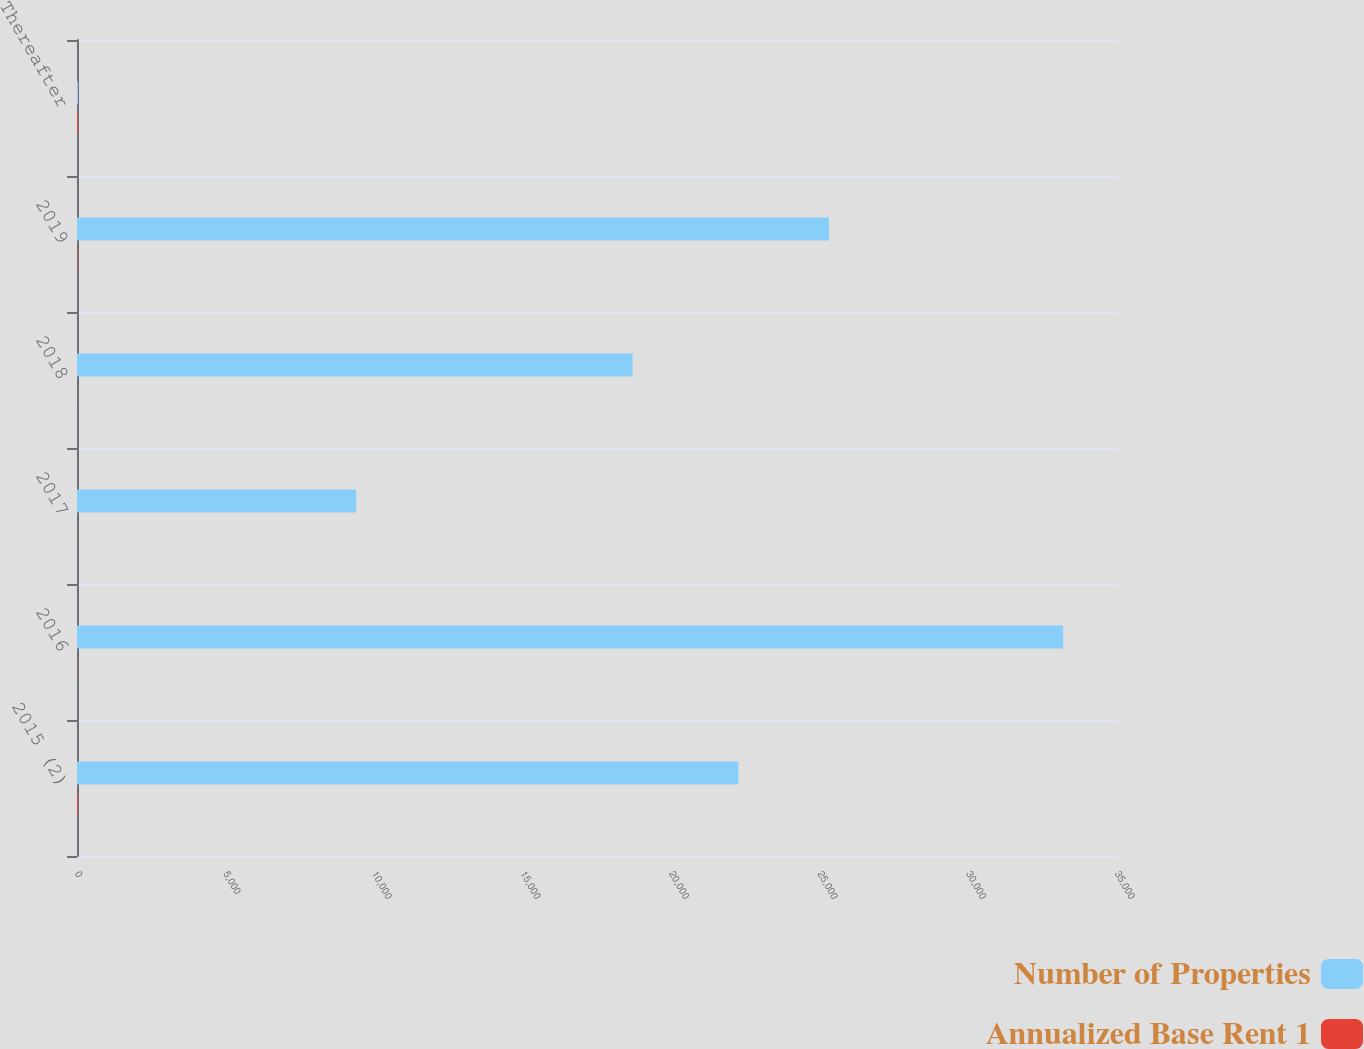Convert chart to OTSL. <chart><loc_0><loc_0><loc_500><loc_500><stacked_bar_chart><ecel><fcel>2015 (2)<fcel>2016<fcel>2017<fcel>2018<fcel>2019<fcel>Thereafter<nl><fcel>Number of Properties<fcel>22257<fcel>33188<fcel>9393<fcel>18697<fcel>25304<fcel>33<nl><fcel>Annualized Base Rent 1<fcel>28<fcel>10<fcel>3<fcel>4<fcel>14<fcel>33<nl></chart> 